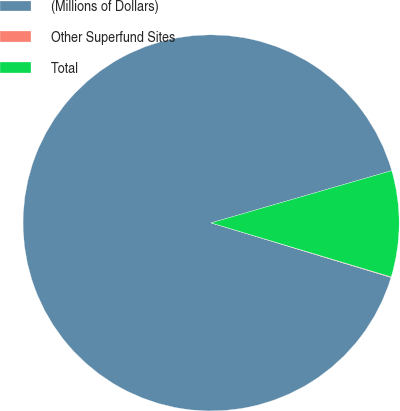Convert chart to OTSL. <chart><loc_0><loc_0><loc_500><loc_500><pie_chart><fcel>(Millions of Dollars)<fcel>Other Superfund Sites<fcel>Total<nl><fcel>90.83%<fcel>0.05%<fcel>9.12%<nl></chart> 